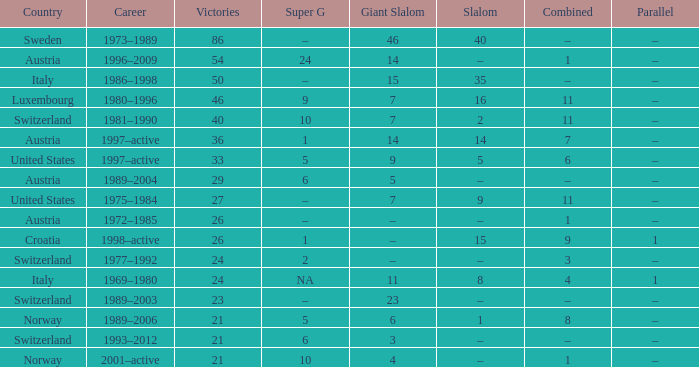What Giant Slalom has Victories larger than 27, a Slalom of –, and a Career of 1996–2009? 14.0. 